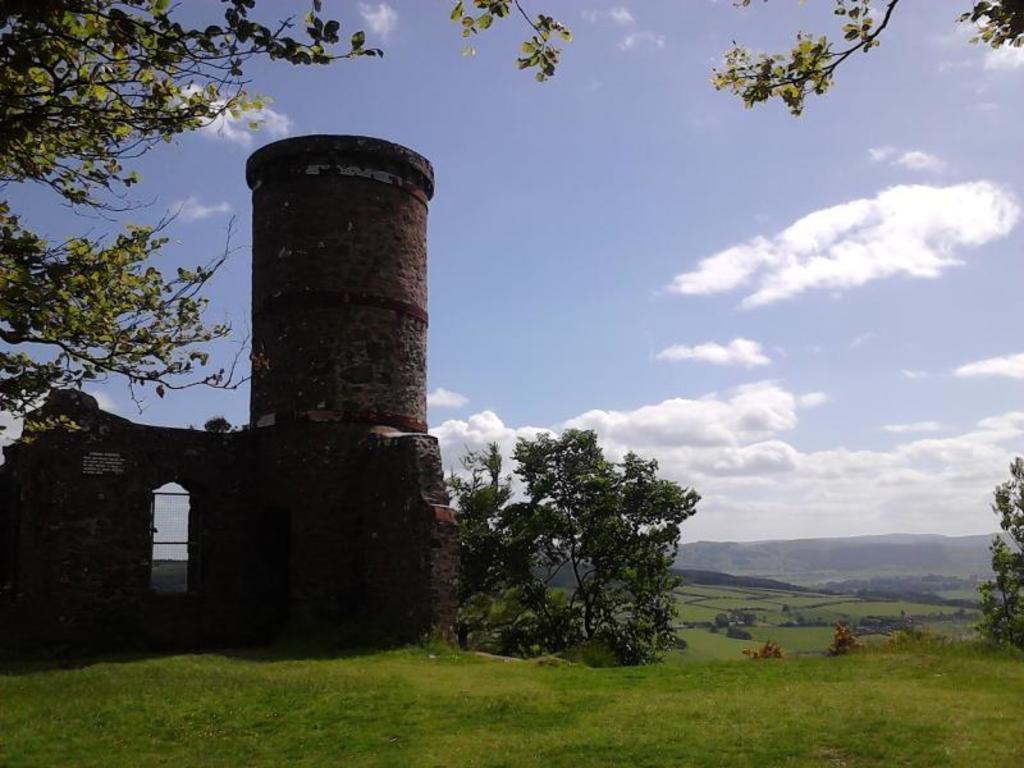Can you describe this image briefly? In this picture we can see a building, trees, mountains, grass and in the background we can see the sky with clouds. 